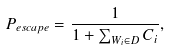<formula> <loc_0><loc_0><loc_500><loc_500>P _ { e s c a p e } = \frac { 1 } { 1 + \sum _ { W _ { i } \in D } { C _ { i } } } ,</formula> 